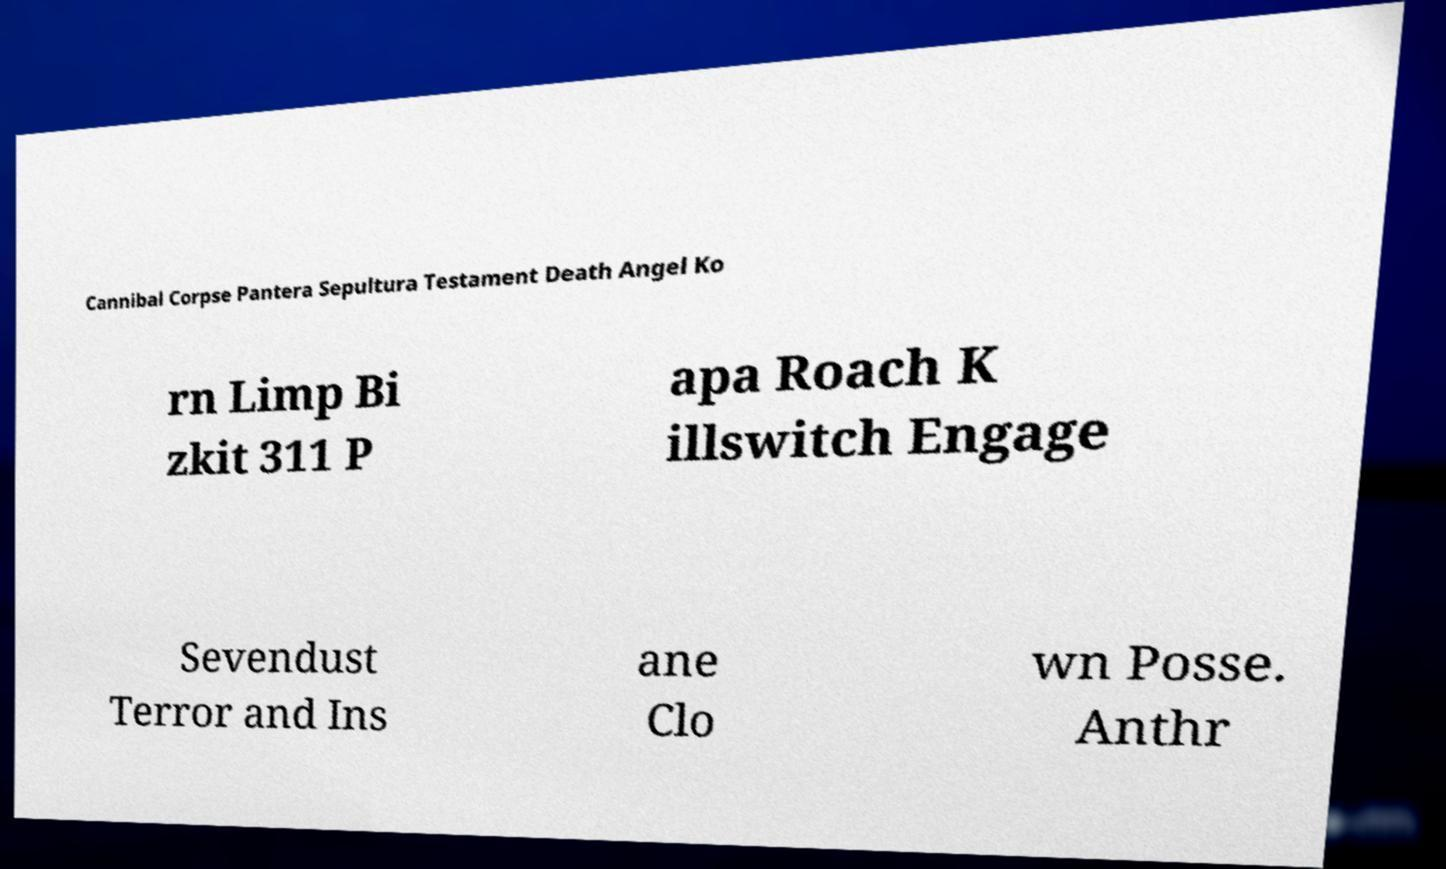Please identify and transcribe the text found in this image. Cannibal Corpse Pantera Sepultura Testament Death Angel Ko rn Limp Bi zkit 311 P apa Roach K illswitch Engage Sevendust Terror and Ins ane Clo wn Posse. Anthr 